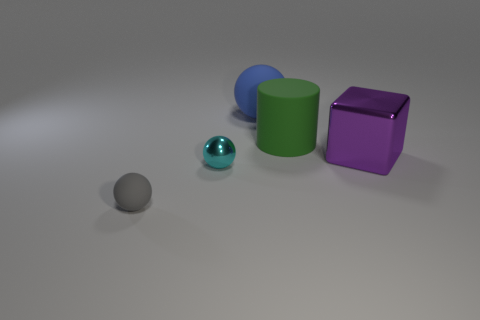Add 2 small cyan metal cylinders. How many objects exist? 7 Subtract all cubes. How many objects are left? 4 Add 4 large shiny blocks. How many large shiny blocks exist? 5 Subtract 0 yellow balls. How many objects are left? 5 Subtract all big blue rubber spheres. Subtract all big green objects. How many objects are left? 3 Add 2 cyan metal spheres. How many cyan metal spheres are left? 3 